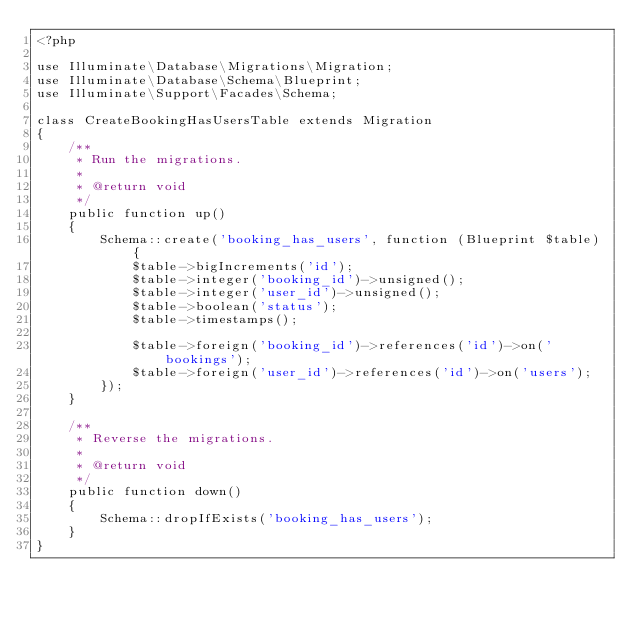<code> <loc_0><loc_0><loc_500><loc_500><_PHP_><?php

use Illuminate\Database\Migrations\Migration;
use Illuminate\Database\Schema\Blueprint;
use Illuminate\Support\Facades\Schema;

class CreateBookingHasUsersTable extends Migration
{
    /**
     * Run the migrations.
     *
     * @return void
     */
    public function up()
    {
        Schema::create('booking_has_users', function (Blueprint $table) {
            $table->bigIncrements('id');
            $table->integer('booking_id')->unsigned();
            $table->integer('user_id')->unsigned();
            $table->boolean('status');
            $table->timestamps();

            $table->foreign('booking_id')->references('id')->on('bookings');
            $table->foreign('user_id')->references('id')->on('users');
        });
    }

    /**
     * Reverse the migrations.
     *
     * @return void
     */
    public function down()
    {
        Schema::dropIfExists('booking_has_users');
    }
}
</code> 